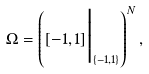Convert formula to latex. <formula><loc_0><loc_0><loc_500><loc_500>\Omega = \left ( [ - 1 , 1 ] \Big | _ { \{ - 1 , 1 \} } \right ) ^ { N } ,</formula> 